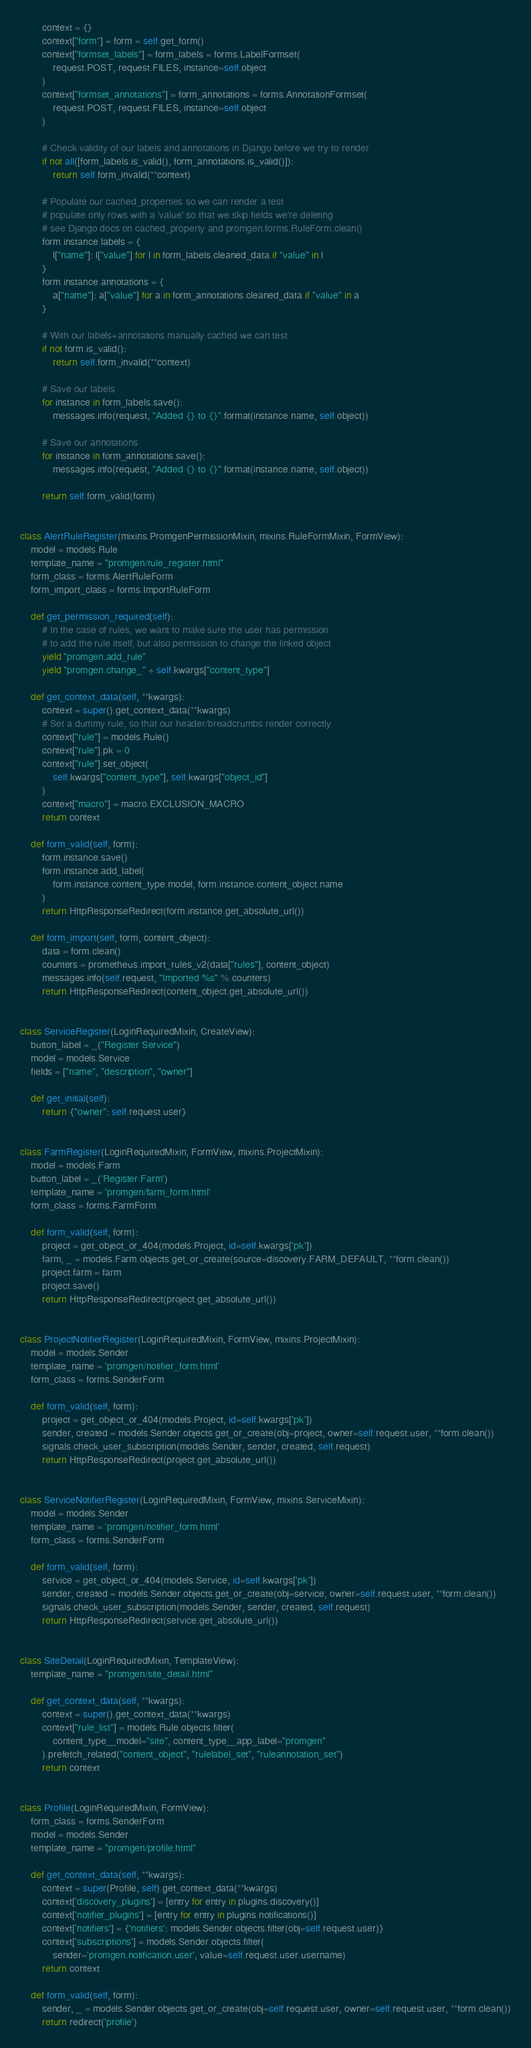<code> <loc_0><loc_0><loc_500><loc_500><_Python_>        context = {}
        context["form"] = form = self.get_form()
        context["formset_labels"] = form_labels = forms.LabelFormset(
            request.POST, request.FILES, instance=self.object
        )
        context["formset_annotations"] = form_annotations = forms.AnnotationFormset(
            request.POST, request.FILES, instance=self.object
        )

        # Check validity of our labels and annotations in Django before we try to render
        if not all([form_labels.is_valid(), form_annotations.is_valid()]):
            return self.form_invalid(**context)

        # Populate our cached_properties so we can render a test
        # populate only rows with a 'value' so that we skip fields we're deleting
        # see Django docs on cached_property and promgen.forms.RuleForm.clean()
        form.instance.labels = {
            l["name"]: l["value"] for l in form_labels.cleaned_data if "value" in l
        }
        form.instance.annotations = {
            a["name"]: a["value"] for a in form_annotations.cleaned_data if "value" in a
        }

        # With our labels+annotations manually cached we can test
        if not form.is_valid():
            return self.form_invalid(**context)

        # Save our labels
        for instance in form_labels.save():
            messages.info(request, "Added {} to {}".format(instance.name, self.object))

        # Save our annotations
        for instance in form_annotations.save():
            messages.info(request, "Added {} to {}".format(instance.name, self.object))

        return self.form_valid(form)


class AlertRuleRegister(mixins.PromgenPermissionMixin, mixins.RuleFormMixin, FormView):
    model = models.Rule
    template_name = "promgen/rule_register.html"
    form_class = forms.AlertRuleForm
    form_import_class = forms.ImportRuleForm

    def get_permission_required(self):
        # In the case of rules, we want to make sure the user has permission
        # to add the rule itself, but also permission to change the linked object
        yield "promgen.add_rule"
        yield "promgen.change_" + self.kwargs["content_type"]

    def get_context_data(self, **kwargs):
        context = super().get_context_data(**kwargs)
        # Set a dummy rule, so that our header/breadcrumbs render correctly
        context["rule"] = models.Rule()
        context["rule"].pk = 0
        context["rule"].set_object(
            self.kwargs["content_type"], self.kwargs["object_id"]
        )
        context["macro"] = macro.EXCLUSION_MACRO
        return context

    def form_valid(self, form):
        form.instance.save()
        form.instance.add_label(
            form.instance.content_type.model, form.instance.content_object.name
        )
        return HttpResponseRedirect(form.instance.get_absolute_url())

    def form_import(self, form, content_object):
        data = form.clean()
        counters = prometheus.import_rules_v2(data["rules"], content_object)
        messages.info(self.request, "Imported %s" % counters)
        return HttpResponseRedirect(content_object.get_absolute_url())


class ServiceRegister(LoginRequiredMixin, CreateView):
    button_label = _("Register Service")
    model = models.Service
    fields = ["name", "description", "owner"]

    def get_initial(self):
        return {"owner": self.request.user}


class FarmRegister(LoginRequiredMixin, FormView, mixins.ProjectMixin):
    model = models.Farm
    button_label = _('Register Farm')
    template_name = 'promgen/farm_form.html'
    form_class = forms.FarmForm

    def form_valid(self, form):
        project = get_object_or_404(models.Project, id=self.kwargs['pk'])
        farm, _ = models.Farm.objects.get_or_create(source=discovery.FARM_DEFAULT, **form.clean())
        project.farm = farm
        project.save()
        return HttpResponseRedirect(project.get_absolute_url())


class ProjectNotifierRegister(LoginRequiredMixin, FormView, mixins.ProjectMixin):
    model = models.Sender
    template_name = 'promgen/notifier_form.html'
    form_class = forms.SenderForm

    def form_valid(self, form):
        project = get_object_or_404(models.Project, id=self.kwargs['pk'])
        sender, created = models.Sender.objects.get_or_create(obj=project, owner=self.request.user, **form.clean())
        signals.check_user_subscription(models.Sender, sender, created, self.request)
        return HttpResponseRedirect(project.get_absolute_url())


class ServiceNotifierRegister(LoginRequiredMixin, FormView, mixins.ServiceMixin):
    model = models.Sender
    template_name = 'promgen/notifier_form.html'
    form_class = forms.SenderForm

    def form_valid(self, form):
        service = get_object_or_404(models.Service, id=self.kwargs['pk'])
        sender, created = models.Sender.objects.get_or_create(obj=service, owner=self.request.user, **form.clean())
        signals.check_user_subscription(models.Sender, sender, created, self.request)
        return HttpResponseRedirect(service.get_absolute_url())


class SiteDetail(LoginRequiredMixin, TemplateView):
    template_name = "promgen/site_detail.html"

    def get_context_data(self, **kwargs):
        context = super().get_context_data(**kwargs)
        context["rule_list"] = models.Rule.objects.filter(
            content_type__model="site", content_type__app_label="promgen"
        ).prefetch_related("content_object", "rulelabel_set", "ruleannotation_set")
        return context


class Profile(LoginRequiredMixin, FormView):
    form_class = forms.SenderForm
    model = models.Sender
    template_name = "promgen/profile.html"

    def get_context_data(self, **kwargs):
        context = super(Profile, self).get_context_data(**kwargs)
        context['discovery_plugins'] = [entry for entry in plugins.discovery()]
        context['notifier_plugins'] = [entry for entry in plugins.notifications()]
        context['notifiers'] = {'notifiers': models.Sender.objects.filter(obj=self.request.user)}
        context['subscriptions'] = models.Sender.objects.filter(
            sender='promgen.notification.user', value=self.request.user.username)
        return context

    def form_valid(self, form):
        sender, _ = models.Sender.objects.get_or_create(obj=self.request.user, owner=self.request.user, **form.clean())
        return redirect('profile')

</code> 